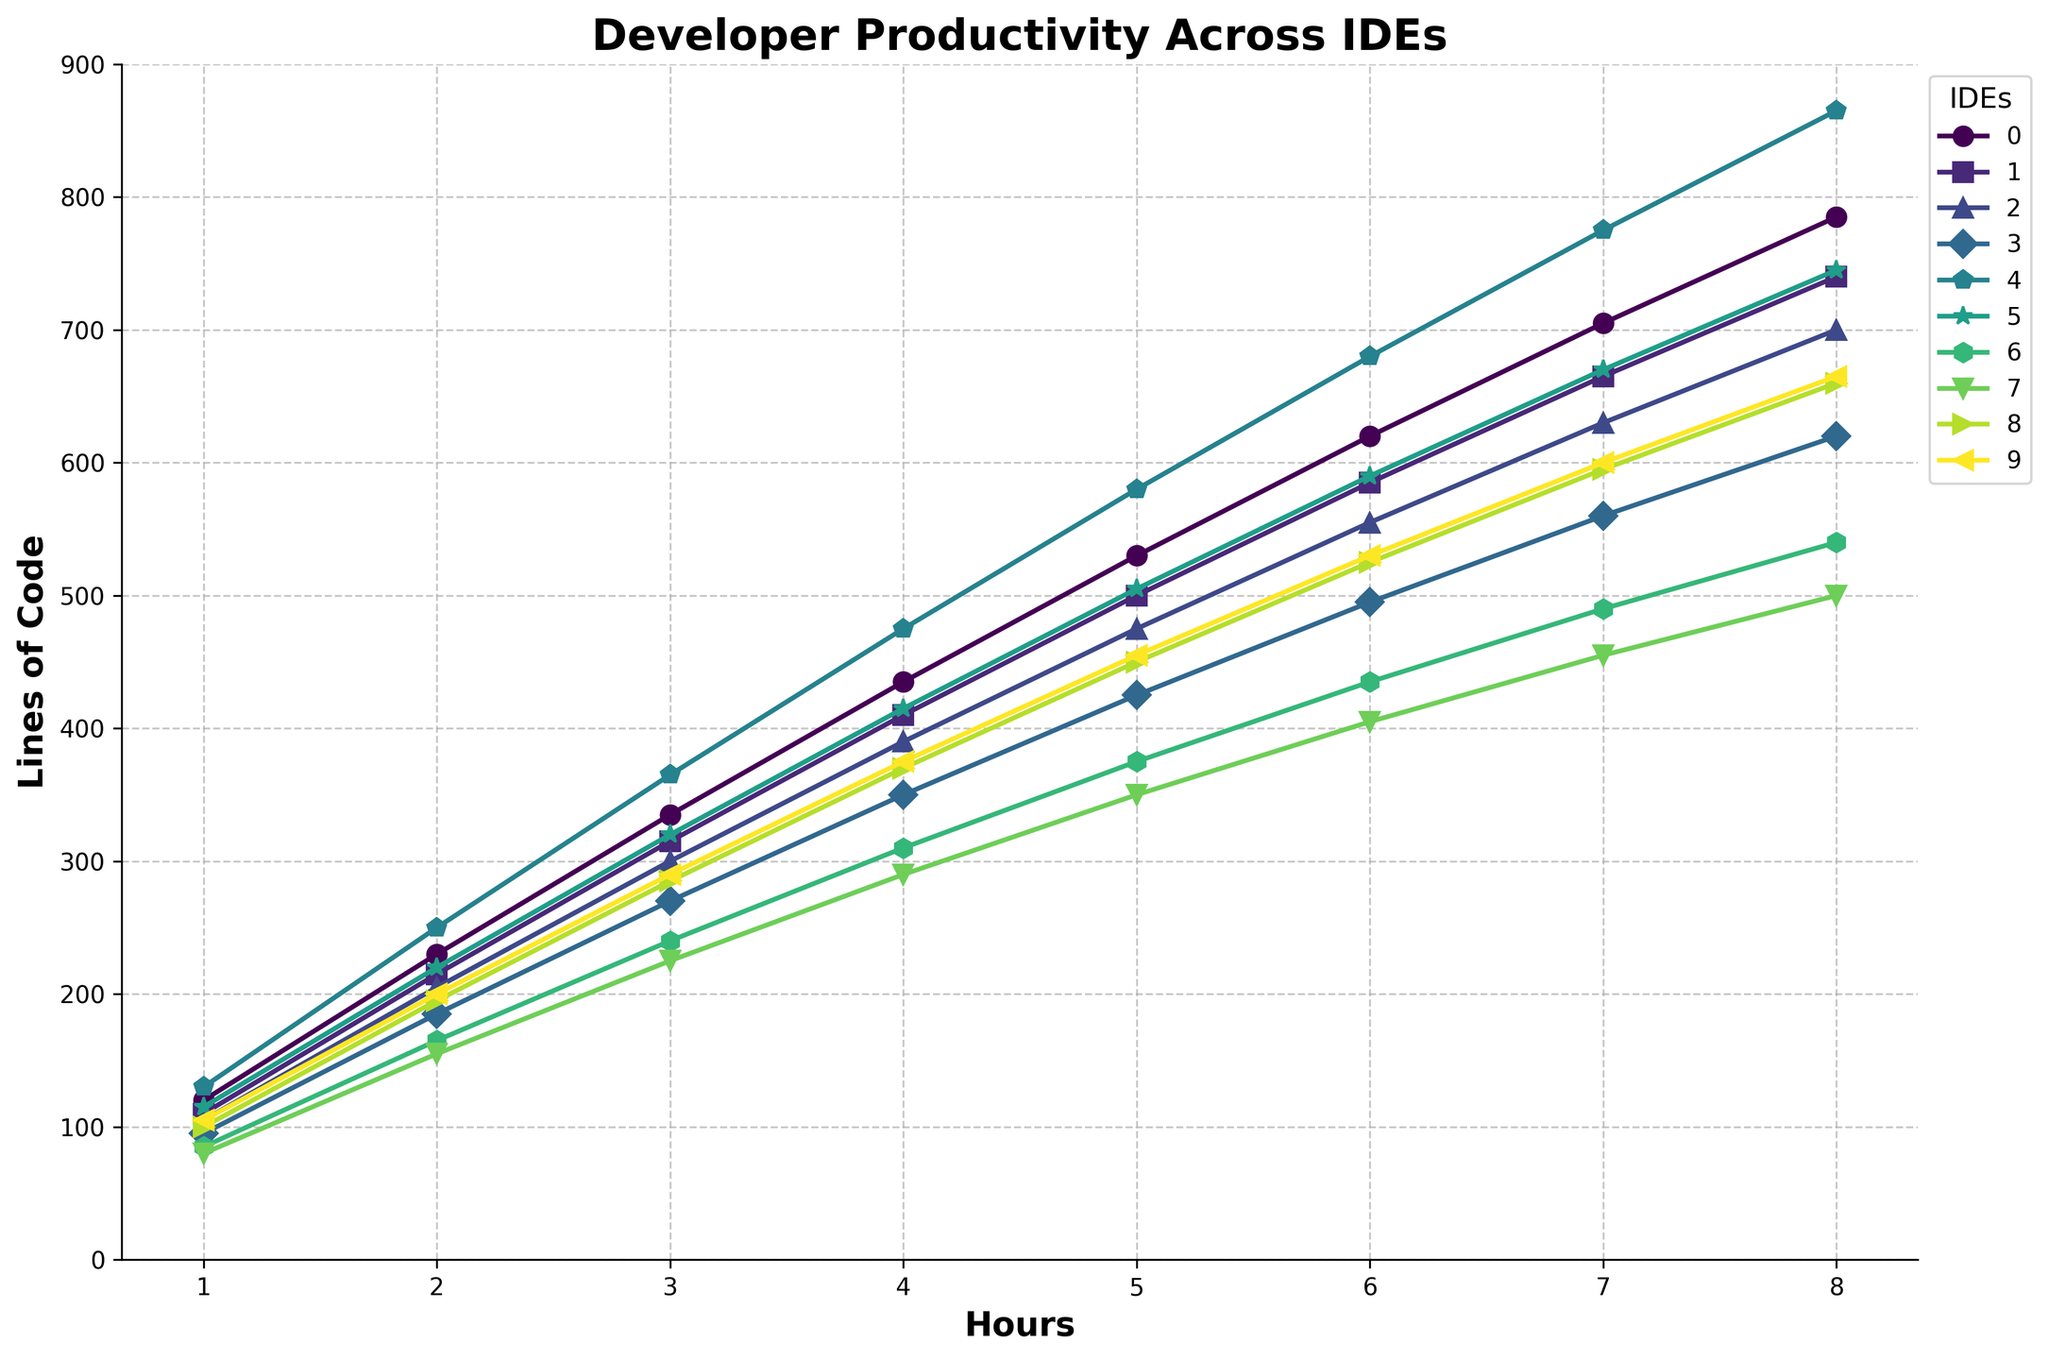Which IDE has the highest productivity at the 8th hour, and what is the lines of code produced? Looking at the figure, identify the line that is highest at the 8th hour (x-axis) and read off the corresponding y-axis value.
Answer: Sublime Text, 865 Which two IDEs show the second and third highest productivity at the 6th hour? Identify the second and third highest points on the y-axis at the 6th hour (x-axis). Compare the values to pick out the correct IDEs.
Answer: Visual Studio Code, IntelliJ IDEA What's the difference in productivity between Vim and Emacs at the 4th hour? Find the y-values (lines of code) for Vim and Emacs at the 4th hour and compute the difference: Vim (310) - Emacs (290).
Answer: 20 Which IDE shows the greatest increase in productivity from the 1st to the 8th hour? Calculate the difference between the 8th and 1st hour values for each IDE and compare them to find the largest increase. Sublime Text's productivity increased from 130 to 865 (865 - 130 = 735)
Answer: Sublime Text Which two IDEs have the least productivity gap at the 7th hour? Look at the y-axis values at the 7th hour for each IDE and calculate the differences. The smallest difference is between PyCharm (630) and Atom (670):
Answer: PyCharm and Atom What is the average productivity of Visual Studio Code and IntelliJ IDEA at the 5th hour? Add the productivity values of Visual Studio Code and IntelliJ IDEA at the 5th hour and divide by 2: (530 + 500) / 2.
Answer: 515 Is Eclipse's productivity ever greater than PyCharm’s? Which hour(s)? Compare the y-values of Eclipse and PyCharm for each hour. Identify any hour where Eclipse’s value is higher. In all hours, PyCharm has higher values, so the answer is none.
Answer: None Which IDE has the most consistent productivity increase per hour? Determine the linearity of each IDE's productivity by checking the increments in y-values across hours. IntelliJ IDEA shows relatively consistent increases.
Answer: IntelliJ IDEA 